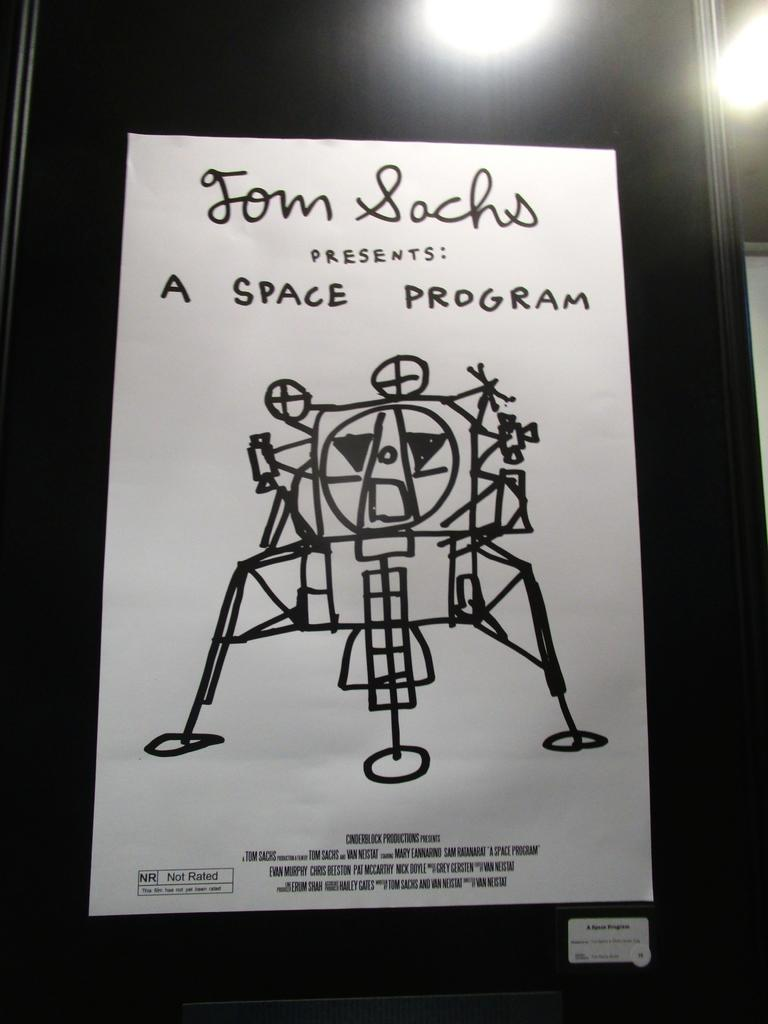<image>
Relay a brief, clear account of the picture shown. A hand drawn movie poster the movie is not yet rated 